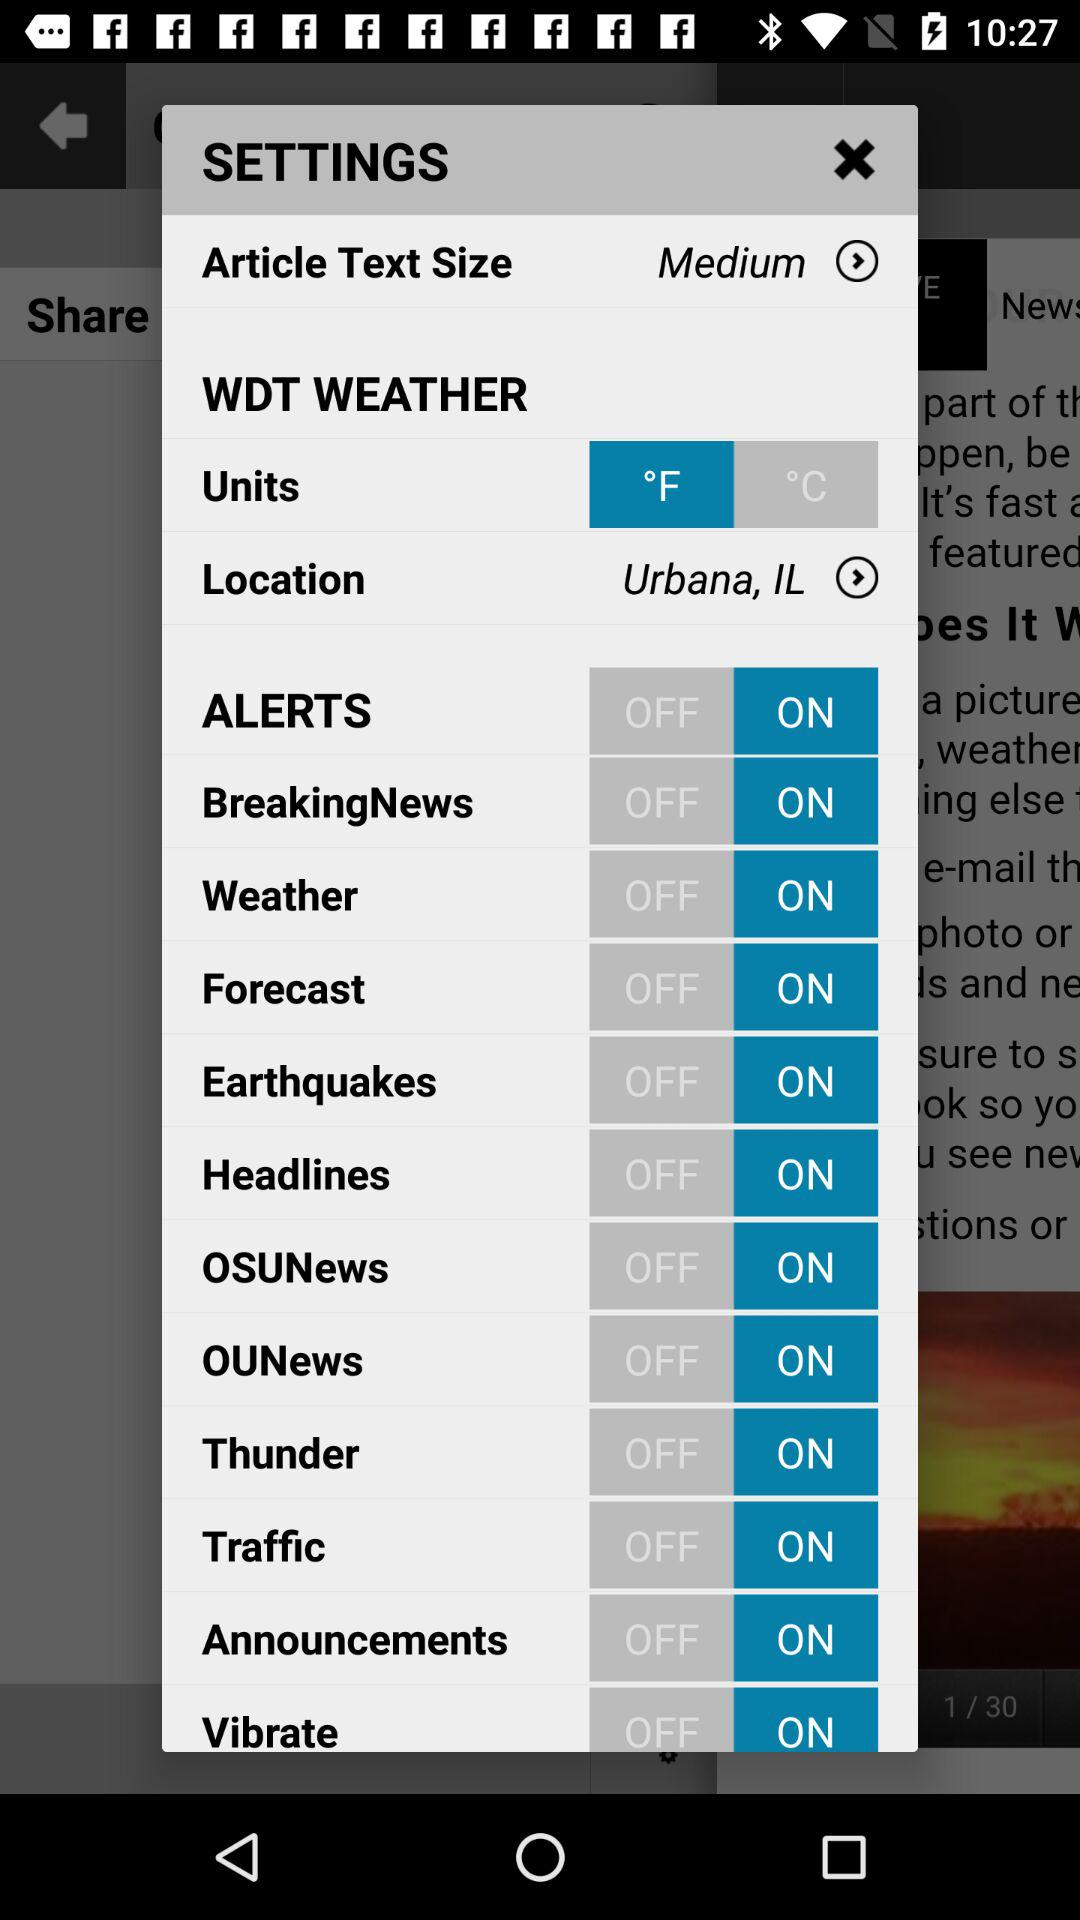What is the status of "Forecast"? The status is "on". 